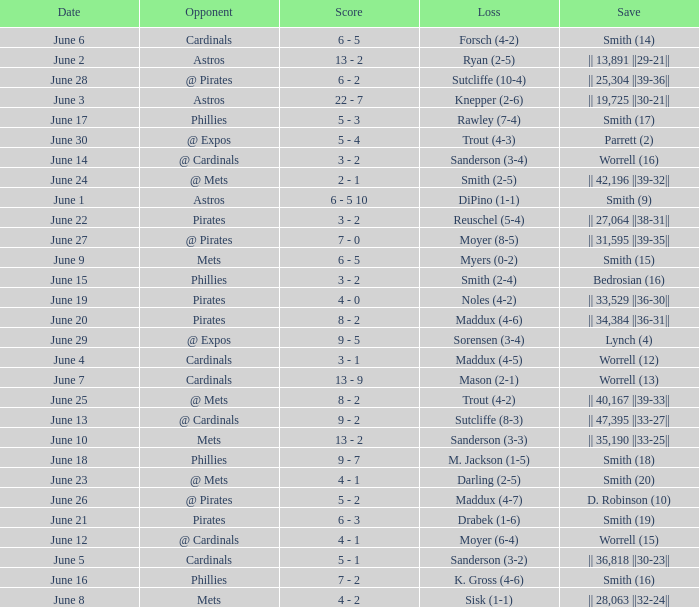On which day did the Chicago Cubs have a loss of trout (4-2)? June 25. 